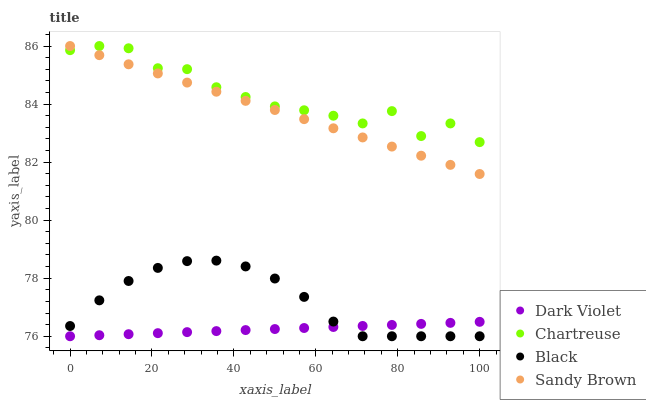Does Dark Violet have the minimum area under the curve?
Answer yes or no. Yes. Does Chartreuse have the maximum area under the curve?
Answer yes or no. Yes. Does Black have the minimum area under the curve?
Answer yes or no. No. Does Black have the maximum area under the curve?
Answer yes or no. No. Is Sandy Brown the smoothest?
Answer yes or no. Yes. Is Chartreuse the roughest?
Answer yes or no. Yes. Is Black the smoothest?
Answer yes or no. No. Is Black the roughest?
Answer yes or no. No. Does Black have the lowest value?
Answer yes or no. Yes. Does Chartreuse have the lowest value?
Answer yes or no. No. Does Chartreuse have the highest value?
Answer yes or no. Yes. Does Black have the highest value?
Answer yes or no. No. Is Dark Violet less than Sandy Brown?
Answer yes or no. Yes. Is Sandy Brown greater than Dark Violet?
Answer yes or no. Yes. Does Chartreuse intersect Sandy Brown?
Answer yes or no. Yes. Is Chartreuse less than Sandy Brown?
Answer yes or no. No. Is Chartreuse greater than Sandy Brown?
Answer yes or no. No. Does Dark Violet intersect Sandy Brown?
Answer yes or no. No. 